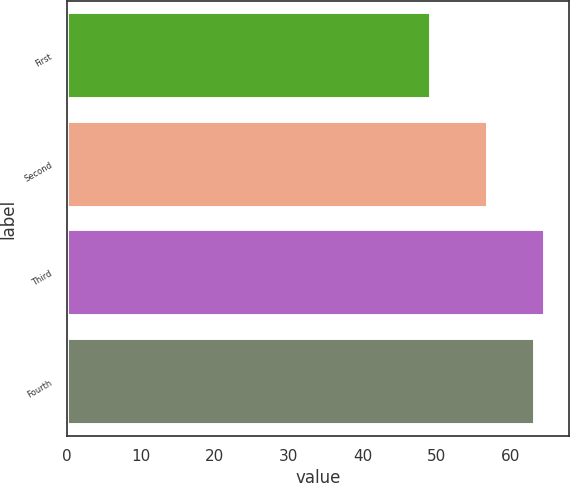Convert chart to OTSL. <chart><loc_0><loc_0><loc_500><loc_500><bar_chart><fcel>First<fcel>Second<fcel>Third<fcel>Fourth<nl><fcel>49.25<fcel>57<fcel>64.73<fcel>63.27<nl></chart> 